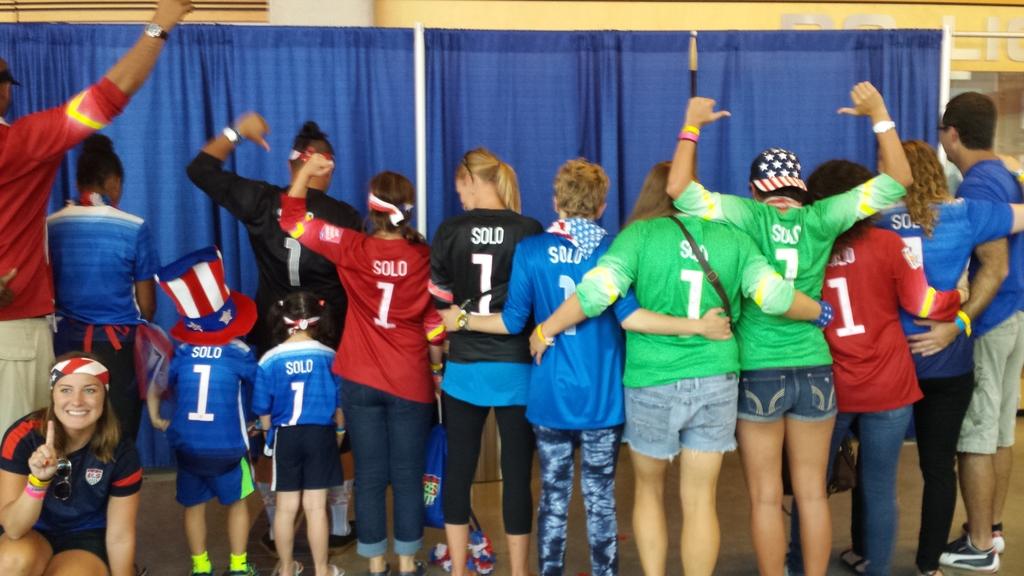What is the number that the whole team has on their shirts?
Your response must be concise. 1. What word is on the back of all the shirts?
Make the answer very short. Solo. 